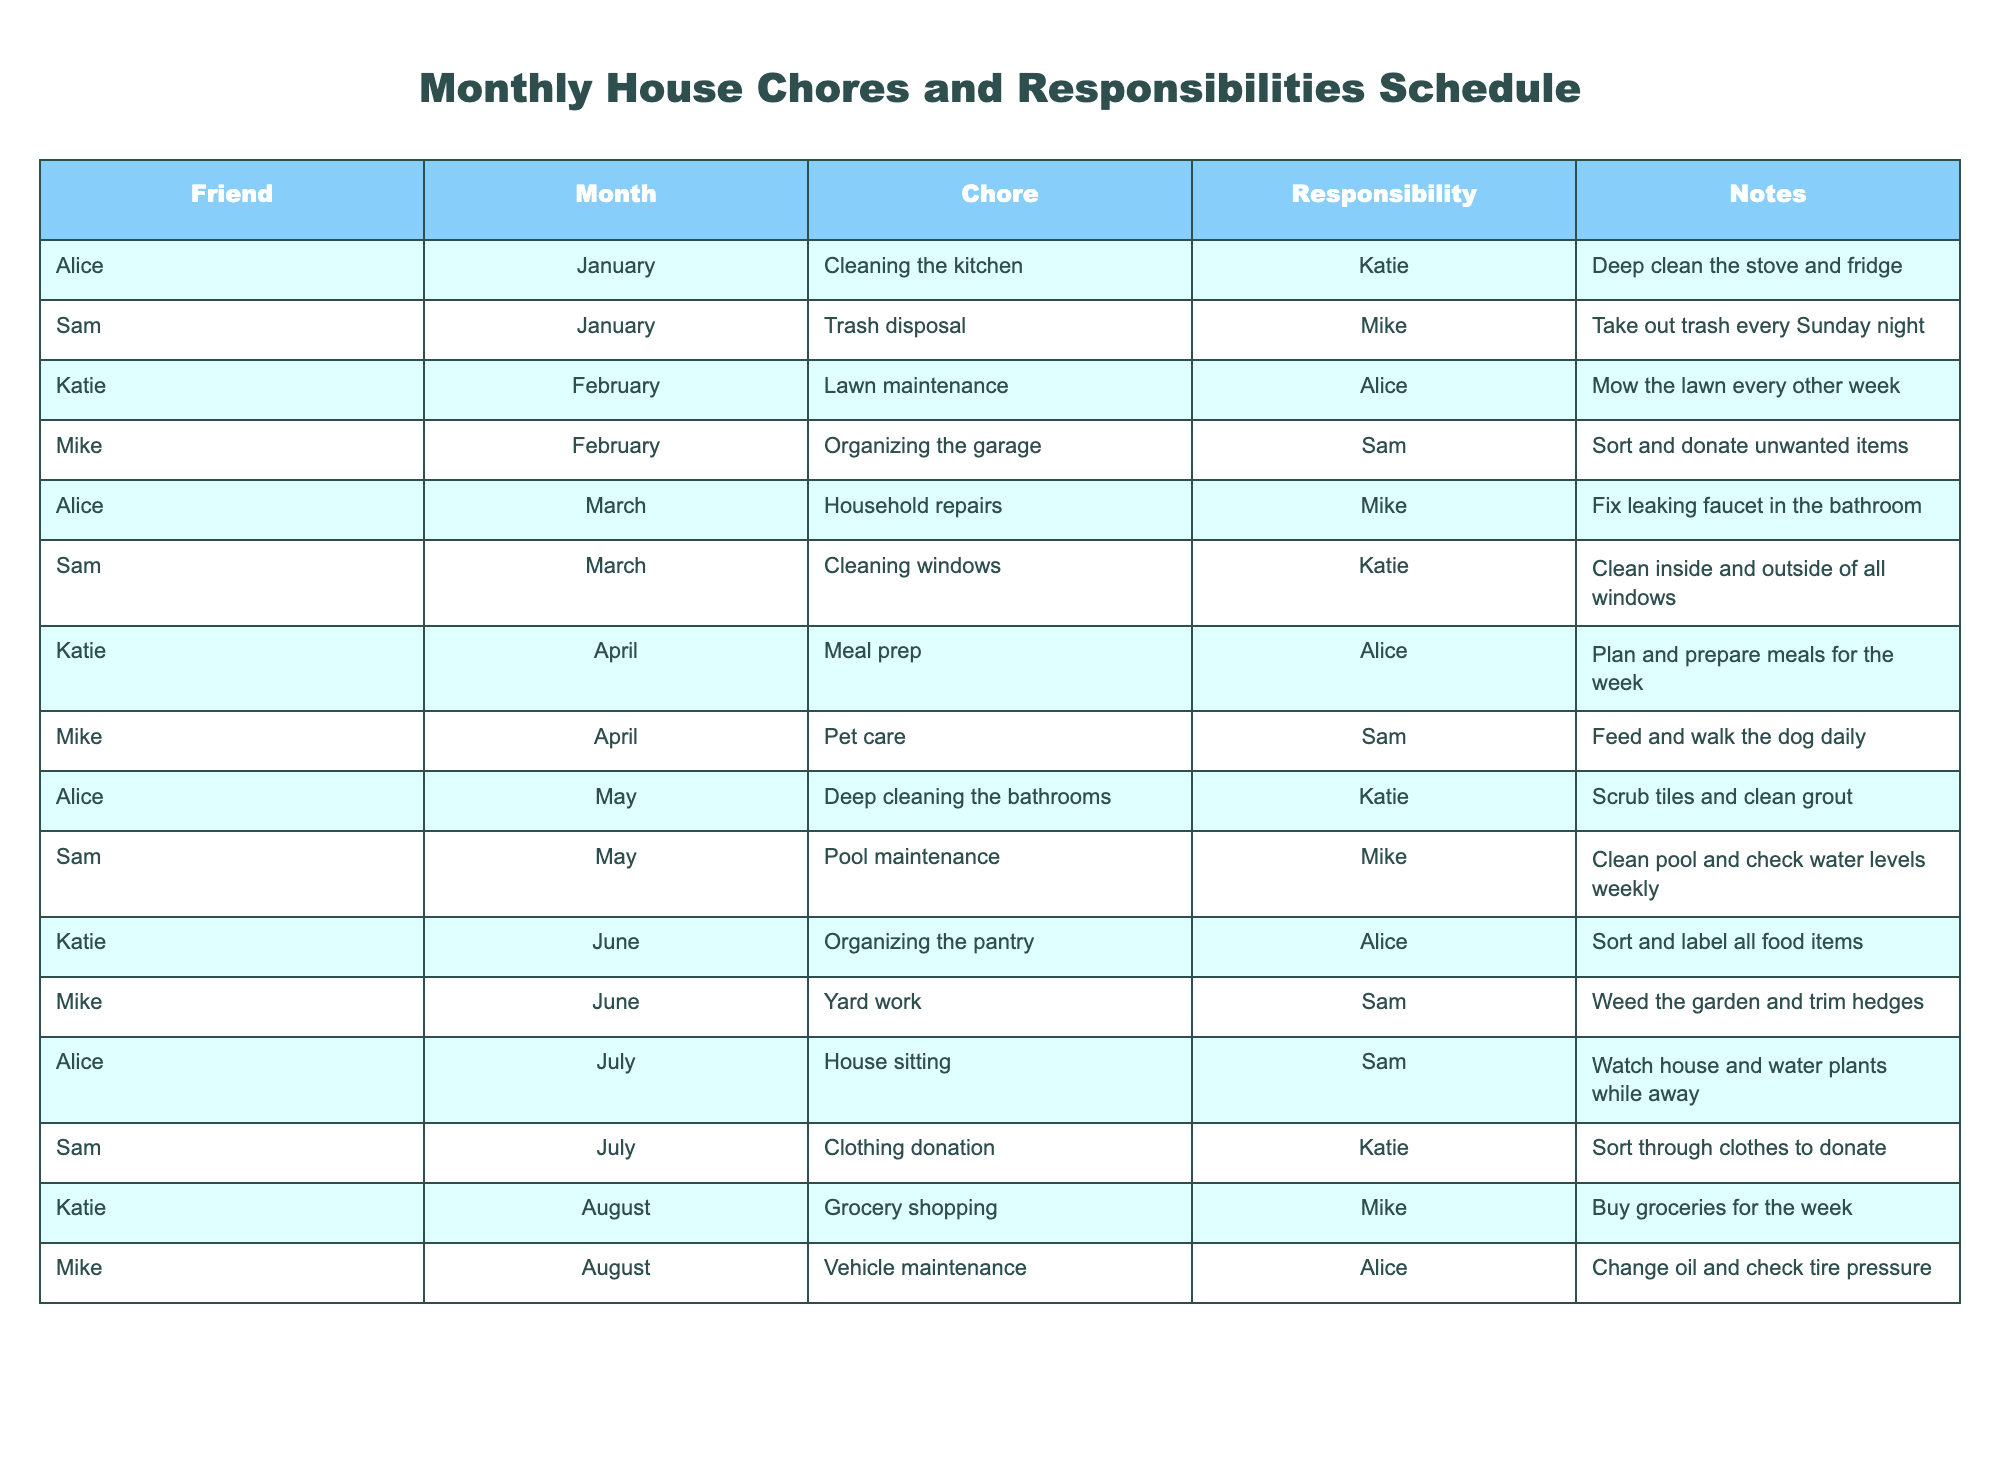What chore does Alice have in March? According to the table, in the month of March, Alice is responsible for "Household repairs", and the specified task is to "Fix leaking faucet in the bathroom". Thus, Alice's chore in March is household repairs.
Answer: Household repairs Who is responsible for lawn maintenance in February? The table indicates that the chore of lawn maintenance in February is assigned to Alice. Therefore, Alice is the one responsible for this task during that month.
Answer: Alice How many different chores are assigned to Sam across all months? Looking through the table, the chores assigned to Sam are "Trash disposal" in January, "Cleaning windows" in March, "Pool maintenance" in May, "Yard work" in June, and "Clothing donation" in July. In total, Sam has 5 different chores assigned to him.
Answer: 5 Is Mike responsible for any chores in July? By examining the table, we can see that Mike does not have any responsibilities listed for July, as the chores for that month are assigned to Sam and Katie. Hence, the answer is no.
Answer: No Which month has the most different chores among friends? Analyzing the table shows that the distribution of chores across the months varies. In March, there are 2 different chores (Household repairs by Alice and Cleaning windows by Sam) while in other months, the maximum is 2 too. Therefore, July, February, and April also have the same number but the distribution remains even. Thus, there isn't a month with more unique chores than others as none exceed two.
Answer: None What is the average number of chores each friend is responsible for? To calculate this, we count the total number of chores (15) and the number of friends (4). Then, we take 15 divided by 4, which gives us an average of 3.75. Therefore, the average number of chores per friend is 3.75.
Answer: 3.75 Are all chores completed by a single person in any month? Looking at the table, each month has different individuals assigned to various chores, and no month features only one person being responsible for all chores. Therefore, the answer is no, not a single person does all chores in any month.
Answer: No How many responsibilities does Katie have in total? From the table, Katie has the following responsibilities: Cleaning the kitchen in January, Lawn maintenance in February, Meal prep in April, and Grocery shopping in August, totaling 4 responsibilities.
Answer: 4 Which friend has the responsibility for vehicle maintenance, and in what month is it assigned? The table shows that the responsibility for vehicle maintenance is assigned to Alice in August. Hence, the answer combines both the name and the month of assignment.
Answer: Alice, August 